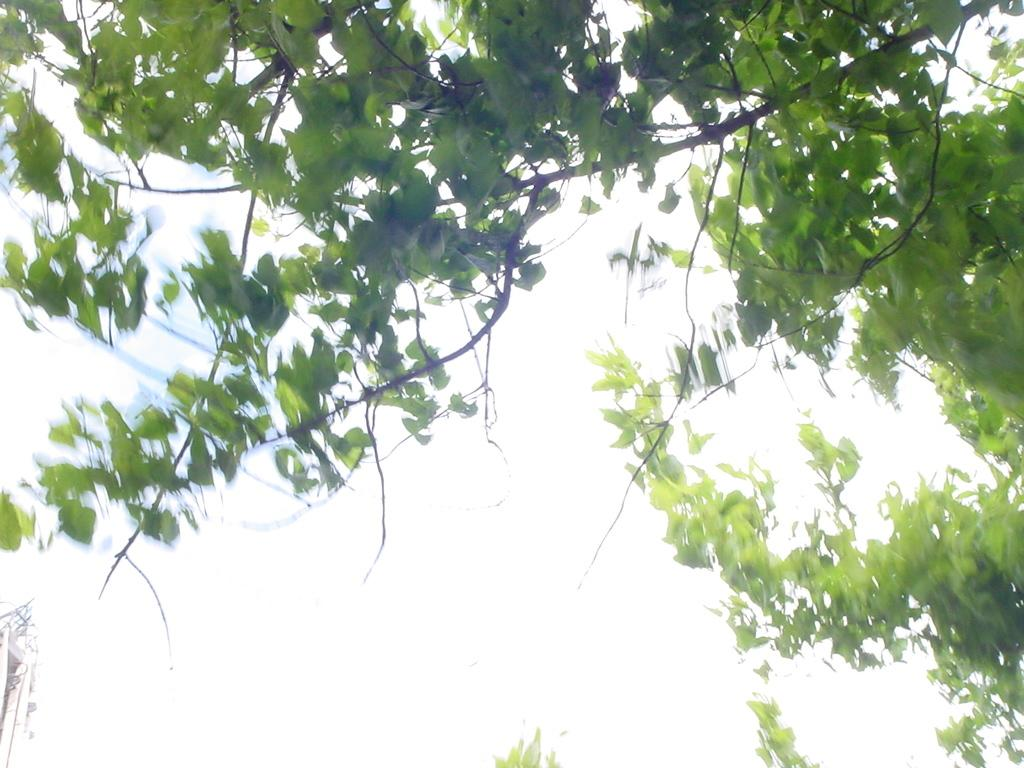What type of plant material is visible in the image? There are green leaves and stems in the image. What color is the background of the image? The background of the image is white. What story is being told by the green leaves and stems in the image? There is no story being told by the green leaves and stems in the image; they are simply plant material. 